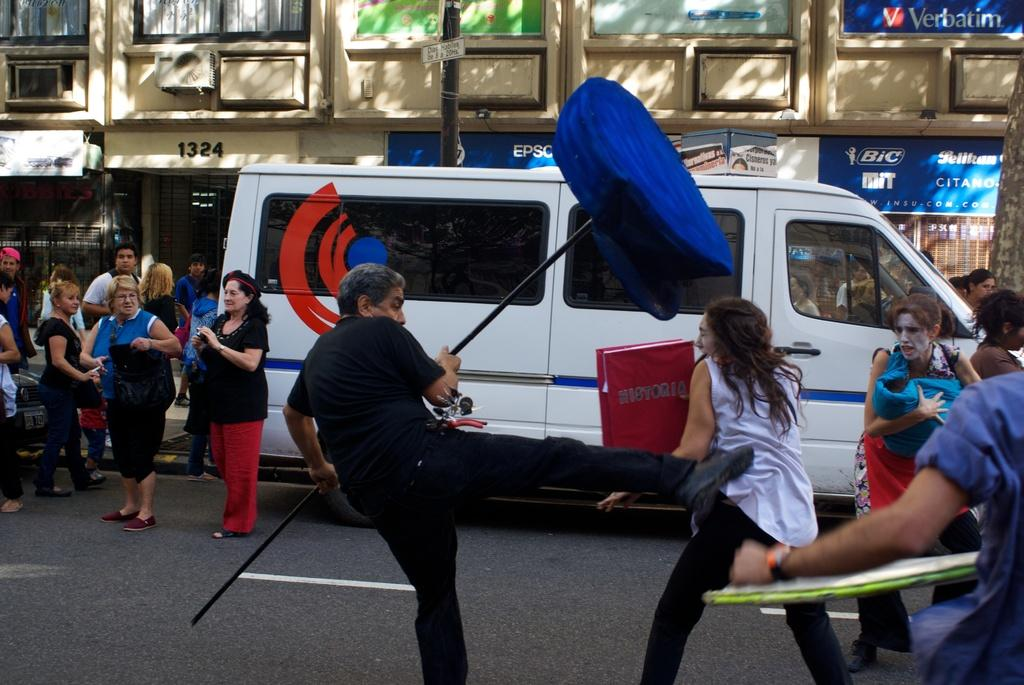Provide a one-sentence caption for the provided image. a man and a woman who is holding a HISTORIA book are fighting in the street with Bic and Verbatim ads on the building. 